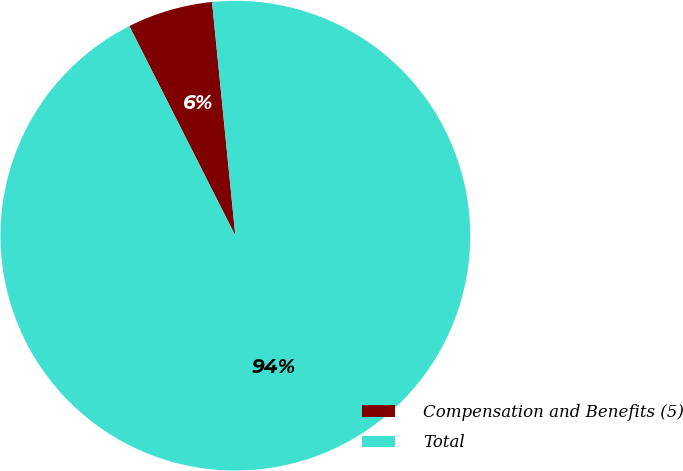Convert chart to OTSL. <chart><loc_0><loc_0><loc_500><loc_500><pie_chart><fcel>Compensation and Benefits (5)<fcel>Total<nl><fcel>5.87%<fcel>94.13%<nl></chart> 